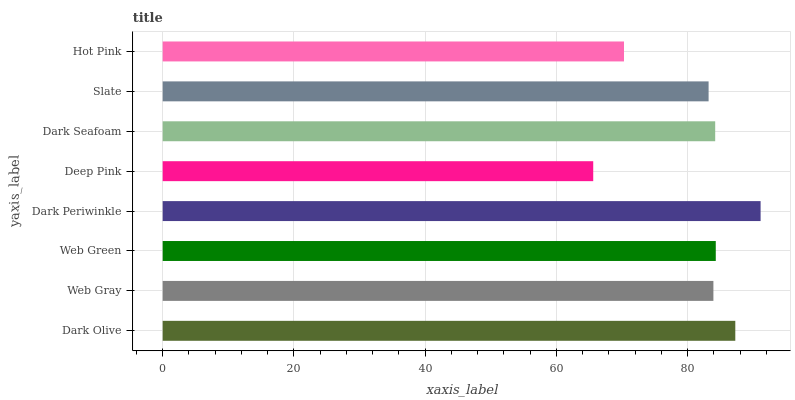Is Deep Pink the minimum?
Answer yes or no. Yes. Is Dark Periwinkle the maximum?
Answer yes or no. Yes. Is Web Gray the minimum?
Answer yes or no. No. Is Web Gray the maximum?
Answer yes or no. No. Is Dark Olive greater than Web Gray?
Answer yes or no. Yes. Is Web Gray less than Dark Olive?
Answer yes or no. Yes. Is Web Gray greater than Dark Olive?
Answer yes or no. No. Is Dark Olive less than Web Gray?
Answer yes or no. No. Is Dark Seafoam the high median?
Answer yes or no. Yes. Is Web Gray the low median?
Answer yes or no. Yes. Is Web Gray the high median?
Answer yes or no. No. Is Web Green the low median?
Answer yes or no. No. 